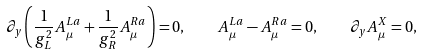Convert formula to latex. <formula><loc_0><loc_0><loc_500><loc_500>\partial _ { y } \left ( \frac { 1 } { g _ { L } ^ { 2 } } A ^ { L a } _ { \mu } + \frac { 1 } { g _ { R } ^ { 2 } } A ^ { R a } _ { \mu } \right ) = 0 , \quad A ^ { L a } _ { \mu } - A ^ { R a } _ { \mu } = 0 , \quad \partial _ { y } A ^ { X } _ { \mu } = 0 ,</formula> 